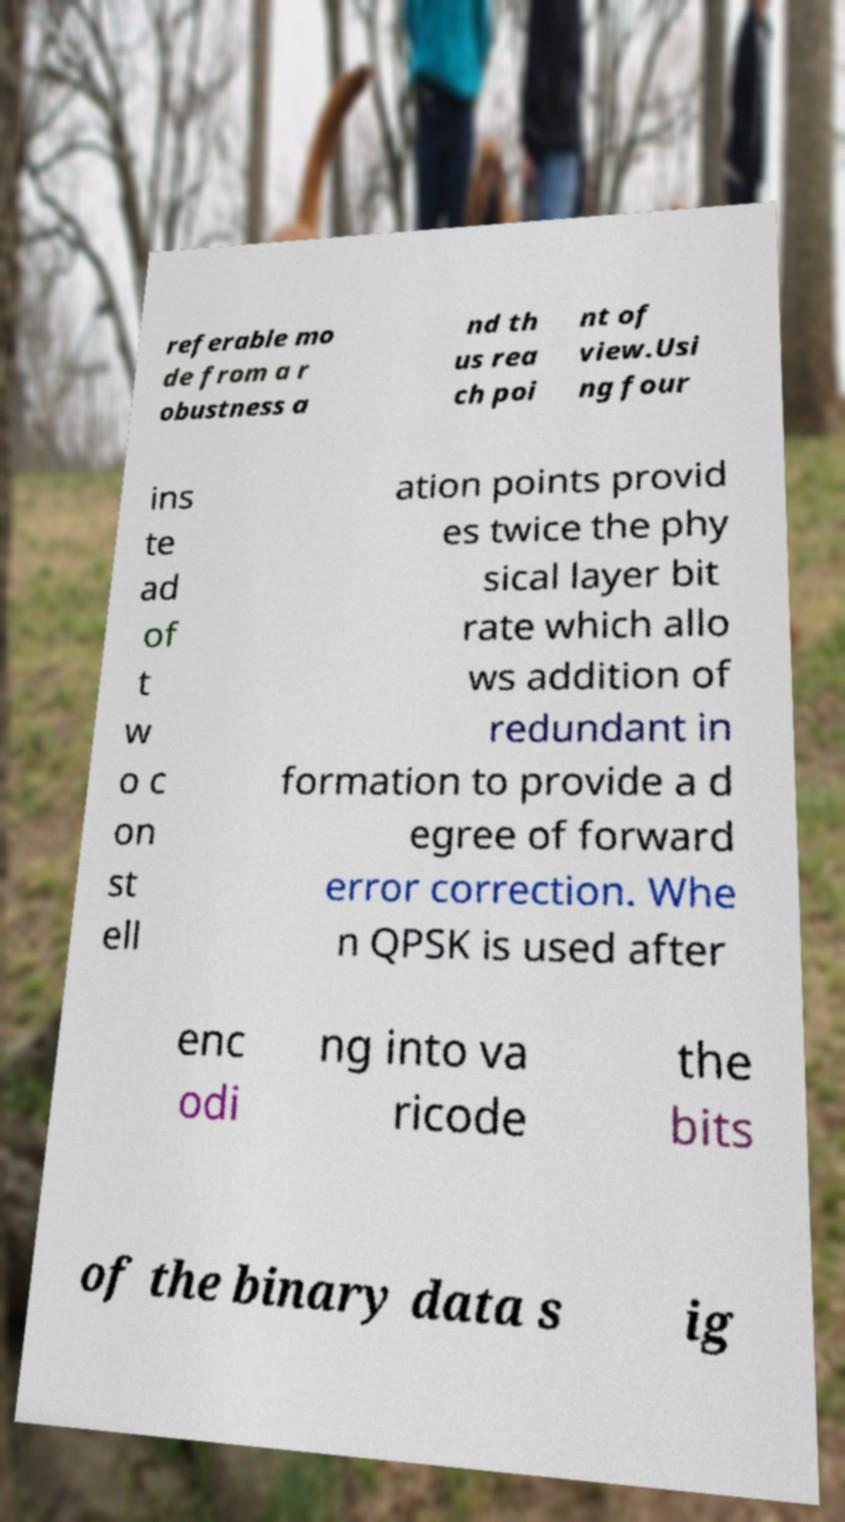There's text embedded in this image that I need extracted. Can you transcribe it verbatim? referable mo de from a r obustness a nd th us rea ch poi nt of view.Usi ng four ins te ad of t w o c on st ell ation points provid es twice the phy sical layer bit rate which allo ws addition of redundant in formation to provide a d egree of forward error correction. Whe n QPSK is used after enc odi ng into va ricode the bits of the binary data s ig 